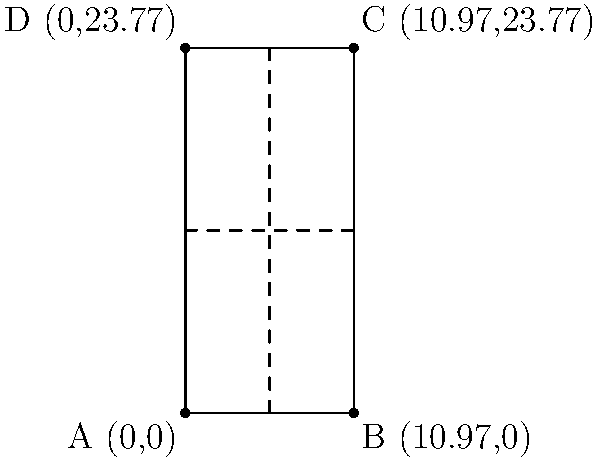As a tennis player advocating for women's sports, you're asked to calculate the area of a standard tennis court for a local women's tournament. The court is represented on a coordinate plane where point A is at (0,0), B at (10.97,0), C at (10.97,23.77), and D at (0,23.77). What is the area of the tennis court in square meters? To calculate the area of the tennis court, we need to follow these steps:

1) The tennis court forms a rectangle on the coordinate plane.

2) To find the area of a rectangle, we use the formula: $A = l \times w$, where $A$ is area, $l$ is length, and $w$ is width.

3) The length of the court is the distance between points A and D (or B and C).
   Length = $y$-coordinate of D - $y$-coordinate of A
   $l = 23.77 - 0 = 23.77$ meters

4) The width of the court is the distance between points A and B (or D and C).
   Width = $x$-coordinate of B - $x$-coordinate of A
   $w = 10.97 - 0 = 10.97$ meters

5) Now we can calculate the area:
   $A = l \times w = 23.77 \times 10.97 = 260.7569$ square meters

Therefore, the area of the tennis court is approximately 260.76 square meters.
Answer: 260.76 m² 